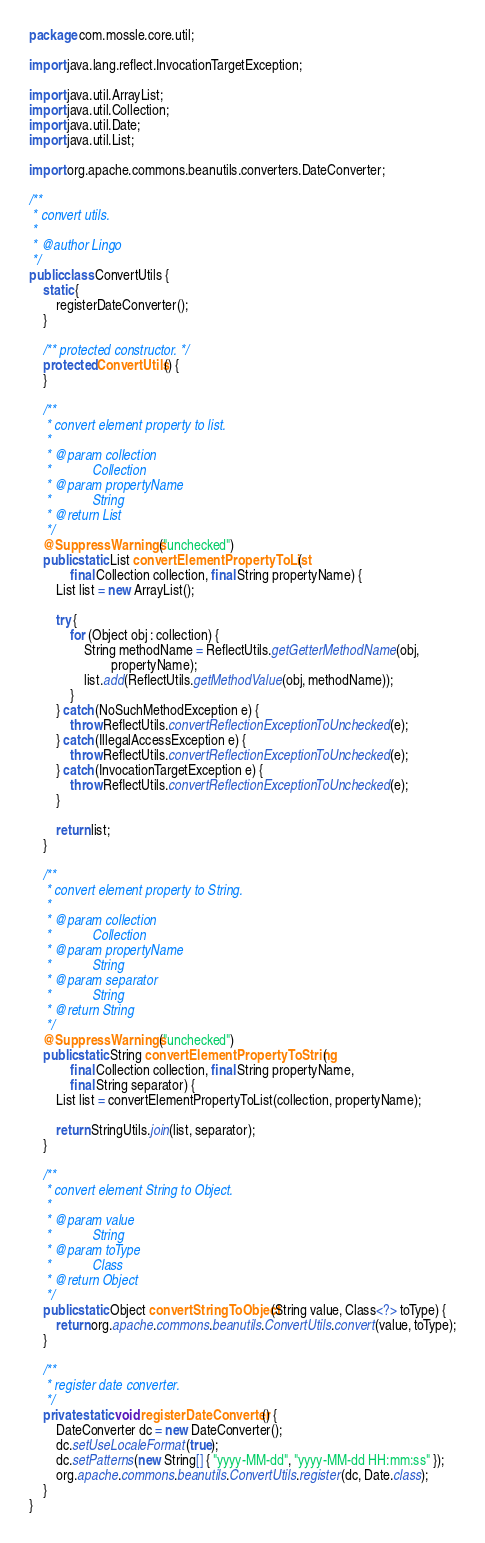Convert code to text. <code><loc_0><loc_0><loc_500><loc_500><_Java_>package com.mossle.core.util;

import java.lang.reflect.InvocationTargetException;

import java.util.ArrayList;
import java.util.Collection;
import java.util.Date;
import java.util.List;

import org.apache.commons.beanutils.converters.DateConverter;

/**
 * convert utils.
 * 
 * @author Lingo
 */
public class ConvertUtils {
    static {
        registerDateConverter();
    }

    /** protected constructor. */
    protected ConvertUtils() {
    }

    /**
     * convert element property to list.
     * 
     * @param collection
     *            Collection
     * @param propertyName
     *            String
     * @return List
     */
    @SuppressWarnings("unchecked")
    public static List convertElementPropertyToList(
            final Collection collection, final String propertyName) {
        List list = new ArrayList();

        try {
            for (Object obj : collection) {
                String methodName = ReflectUtils.getGetterMethodName(obj,
                        propertyName);
                list.add(ReflectUtils.getMethodValue(obj, methodName));
            }
        } catch (NoSuchMethodException e) {
            throw ReflectUtils.convertReflectionExceptionToUnchecked(e);
        } catch (IllegalAccessException e) {
            throw ReflectUtils.convertReflectionExceptionToUnchecked(e);
        } catch (InvocationTargetException e) {
            throw ReflectUtils.convertReflectionExceptionToUnchecked(e);
        }

        return list;
    }

    /**
     * convert element property to String.
     * 
     * @param collection
     *            Collection
     * @param propertyName
     *            String
     * @param separator
     *            String
     * @return String
     */
    @SuppressWarnings("unchecked")
    public static String convertElementPropertyToString(
            final Collection collection, final String propertyName,
            final String separator) {
        List list = convertElementPropertyToList(collection, propertyName);

        return StringUtils.join(list, separator);
    }

    /**
     * convert element String to Object.
     * 
     * @param value
     *            String
     * @param toType
     *            Class
     * @return Object
     */
    public static Object convertStringToObject(String value, Class<?> toType) {
        return org.apache.commons.beanutils.ConvertUtils.convert(value, toType);
    }

    /**
     * register date converter.
     */
    private static void registerDateConverter() {
        DateConverter dc = new DateConverter();
        dc.setUseLocaleFormat(true);
        dc.setPatterns(new String[] { "yyyy-MM-dd", "yyyy-MM-dd HH:mm:ss" });
        org.apache.commons.beanutils.ConvertUtils.register(dc, Date.class);
    }
}
</code> 